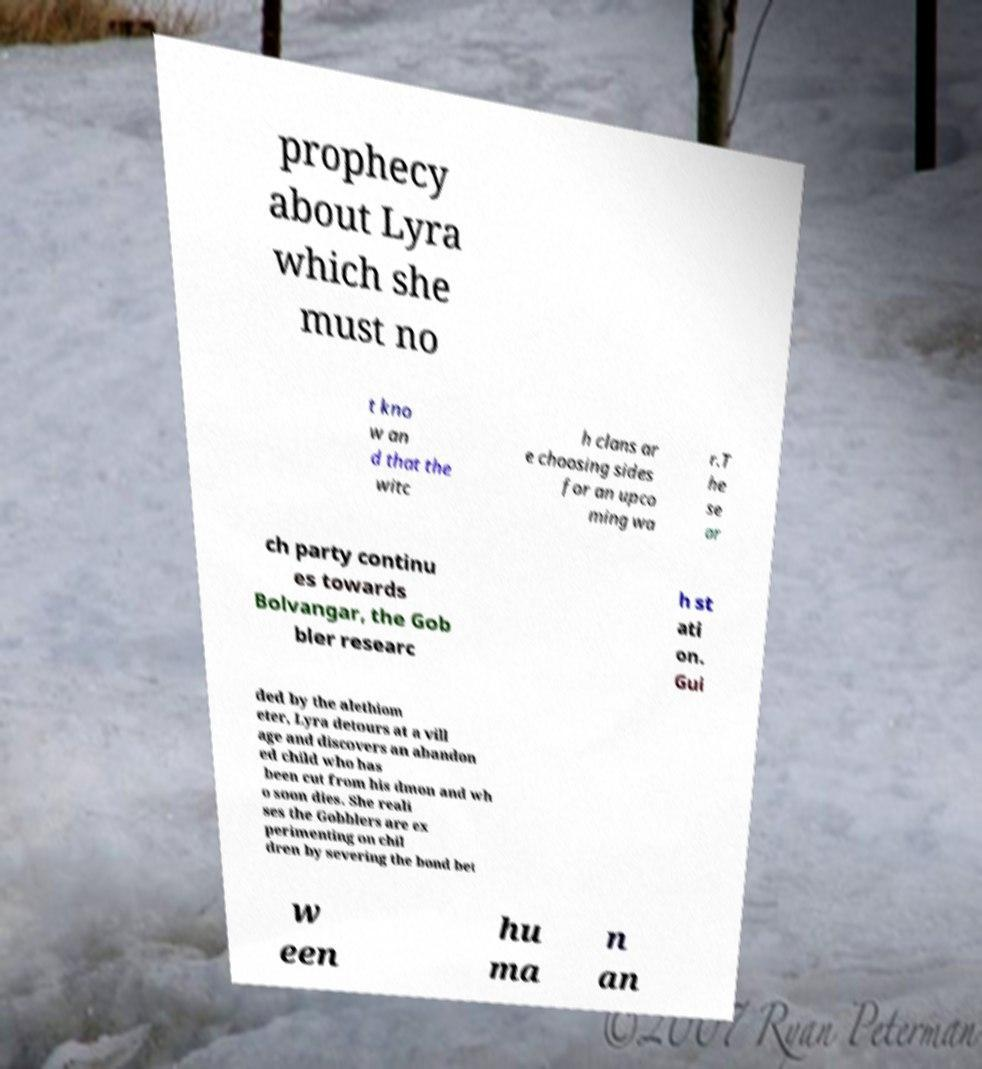What messages or text are displayed in this image? I need them in a readable, typed format. prophecy about Lyra which she must no t kno w an d that the witc h clans ar e choosing sides for an upco ming wa r.T he se ar ch party continu es towards Bolvangar, the Gob bler researc h st ati on. Gui ded by the alethiom eter, Lyra detours at a vill age and discovers an abandon ed child who has been cut from his dmon and wh o soon dies. She reali ses the Gobblers are ex perimenting on chil dren by severing the bond bet w een hu ma n an 